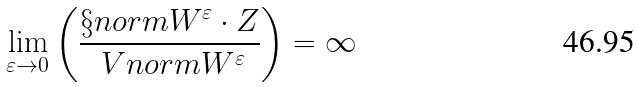<formula> <loc_0><loc_0><loc_500><loc_500>\lim _ { \varepsilon \to 0 } \left ( \frac { \S n o r m { W ^ { \varepsilon } \cdot Z } } { \ V n o r m { W ^ { \varepsilon } } } \right ) = \infty</formula> 